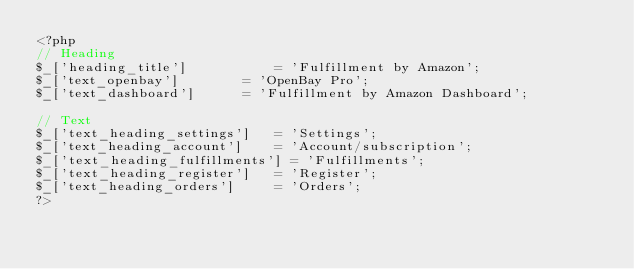Convert code to text. <code><loc_0><loc_0><loc_500><loc_500><_PHP_><?php
// Heading
$_['heading_title']         	= 'Fulfillment by Amazon';
$_['text_openbay']				= 'OpenBay Pro';
$_['text_dashboard']			= 'Fulfillment by Amazon Dashboard';

// Text
$_['text_heading_settings'] 	= 'Settings';
$_['text_heading_account'] 		= 'Account/subscription';
$_['text_heading_fulfillments'] = 'Fulfillments';
$_['text_heading_register'] 	= 'Register';
$_['text_heading_orders'] 		= 'Orders';
?></code> 